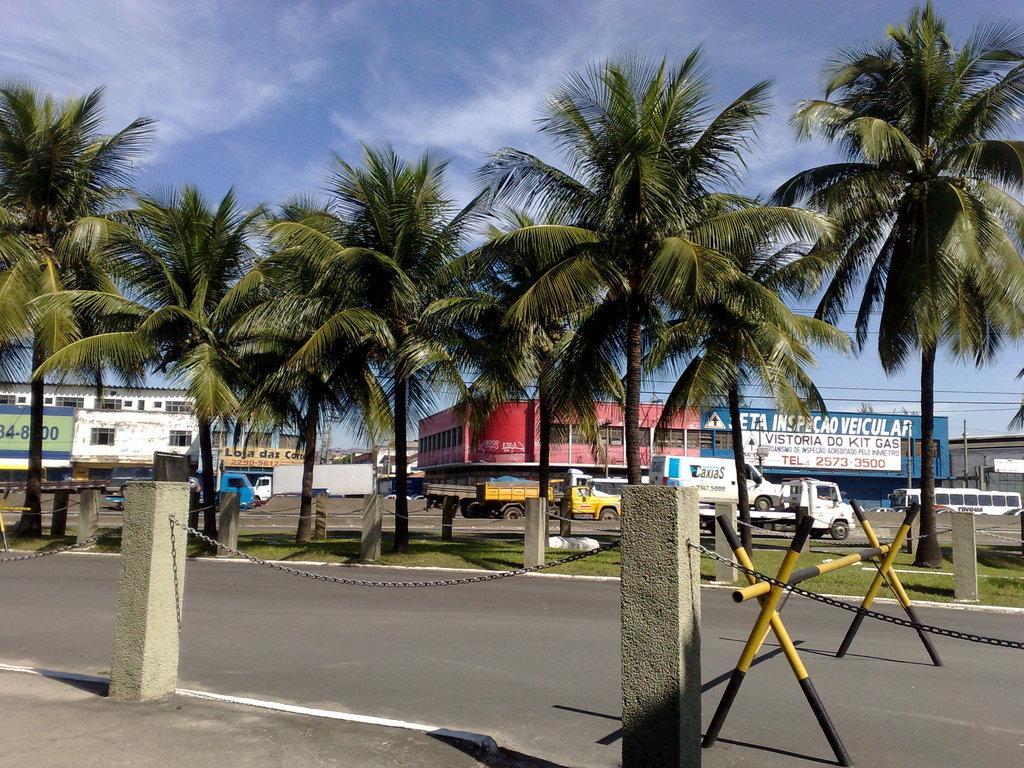Could you give a brief overview of what you see in this image? In this picture we can see a hurdle on the road, fences, grass, trees, vehicles, name boards, buildings and some objects and in the background we can see the sky. 